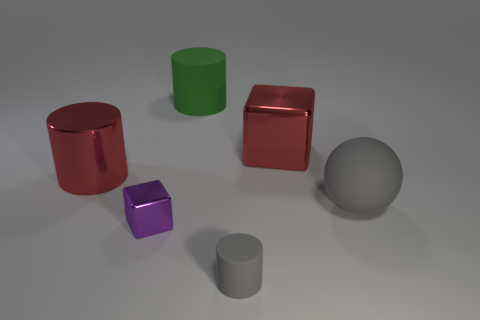What number of tiny metallic blocks are there?
Keep it short and to the point. 1. Are the big gray object and the cylinder that is in front of the red cylinder made of the same material?
Your answer should be very brief. Yes. There is a big thing that is the same color as the metallic cylinder; what material is it?
Offer a very short reply. Metal. What number of other shiny objects are the same color as the tiny metallic thing?
Give a very brief answer. 0. How big is the green cylinder?
Give a very brief answer. Large. There is a green thing; is its shape the same as the gray matte thing on the left side of the big block?
Offer a terse response. Yes. There is another cylinder that is the same material as the gray cylinder; what color is it?
Your response must be concise. Green. There is a metallic block in front of the ball; what size is it?
Provide a short and direct response. Small. Are there fewer large gray rubber spheres that are behind the matte ball than big purple spheres?
Ensure brevity in your answer.  No. Does the big ball have the same color as the tiny shiny object?
Your answer should be very brief. No. 